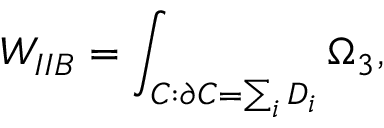<formula> <loc_0><loc_0><loc_500><loc_500>W _ { I I B } = \int _ { C \colon \partial C = \sum _ { i } D _ { i } } \Omega _ { 3 } ,</formula> 